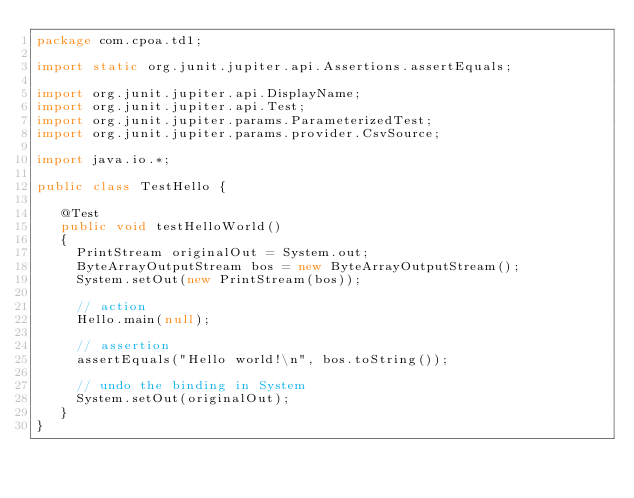<code> <loc_0><loc_0><loc_500><loc_500><_Java_>package com.cpoa.td1;

import static org.junit.jupiter.api.Assertions.assertEquals;

import org.junit.jupiter.api.DisplayName;
import org.junit.jupiter.api.Test;
import org.junit.jupiter.params.ParameterizedTest;
import org.junit.jupiter.params.provider.CsvSource;

import java.io.*;

public class TestHello {

   @Test
   public void testHelloWorld()
   {
     PrintStream originalOut = System.out;
     ByteArrayOutputStream bos = new ByteArrayOutputStream();
     System.setOut(new PrintStream(bos));

     // action
     Hello.main(null);

     // assertion
     assertEquals("Hello world!\n", bos.toString());

     // undo the binding in System
     System.setOut(originalOut);
   }
}</code> 